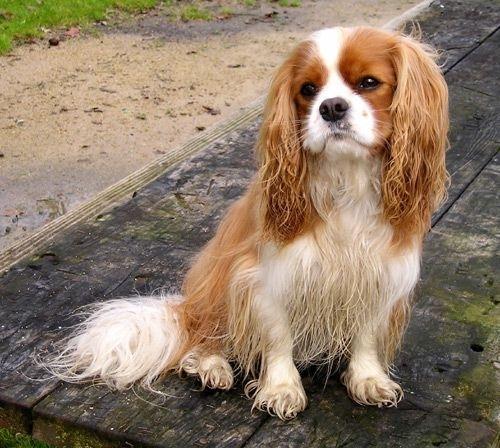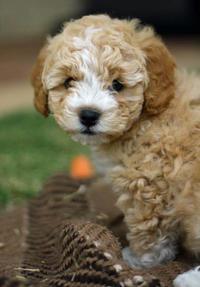The first image is the image on the left, the second image is the image on the right. Examine the images to the left and right. Is the description "The dog in the image on the right is sitting on green grass." accurate? Answer yes or no. No. 